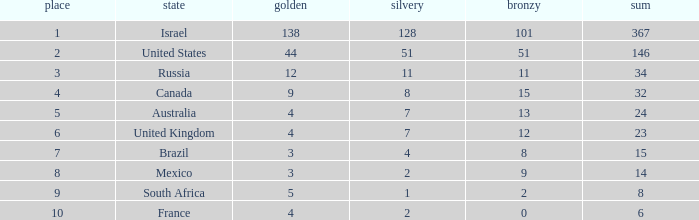What is the gold medal count for the country with a total greater than 32 and more than 128 silvers? None. 